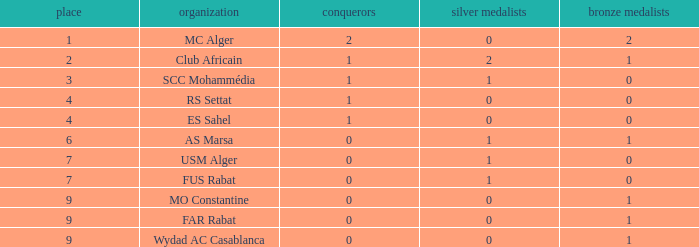How many Winners have a Third of 1, and Runners-up smaller than 0? 0.0. 